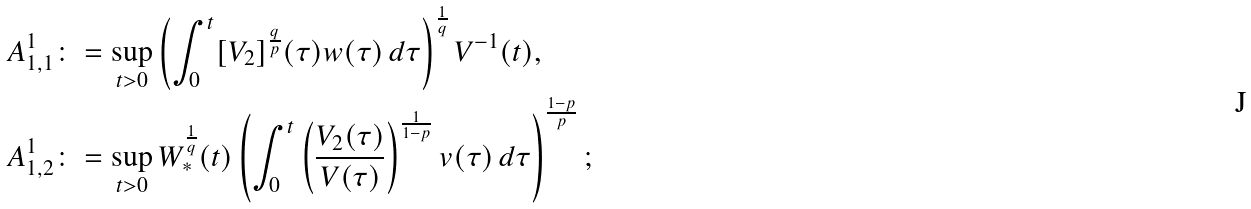<formula> <loc_0><loc_0><loc_500><loc_500>A _ { 1 , 1 } ^ { 1 } \colon & = \sup _ { t > 0 } \left ( \int _ { 0 } ^ { t } [ V _ { 2 } ] ^ { \frac { q } { p } } ( \tau ) w ( \tau ) \, d \tau \right ) ^ { \frac { 1 } { q } } V ^ { - 1 } ( t ) , \\ A _ { 1 , 2 } ^ { 1 } \colon & = \sup _ { t > 0 } W _ { * } ^ { \frac { 1 } { q } } ( t ) \left ( \int _ { 0 } ^ { t } \left ( \frac { V _ { 2 } ( \tau ) } { V ( \tau ) } \right ) ^ { \frac { 1 } { 1 - p } } v ( \tau ) \, d \tau \right ) ^ { \frac { 1 - p } { p } } ;</formula> 